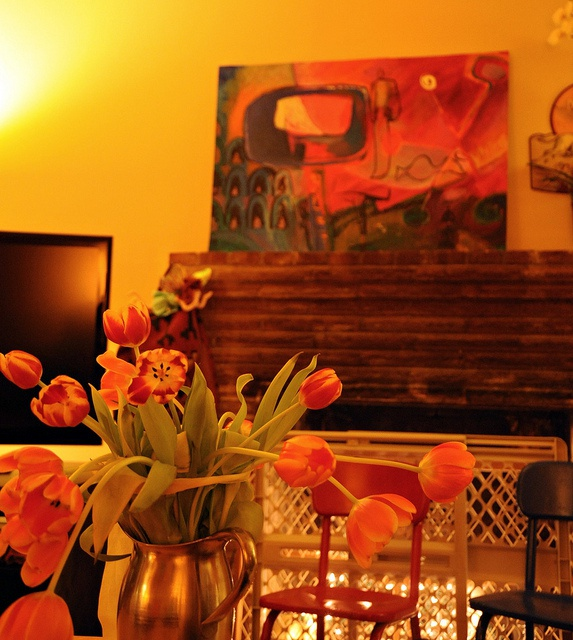Describe the objects in this image and their specific colors. I can see chair in khaki, brown, and red tones, tv in khaki, black, maroon, and red tones, tv in khaki, black, maroon, and red tones, vase in khaki, maroon, brown, and red tones, and chair in khaki, black, maroon, and brown tones in this image. 